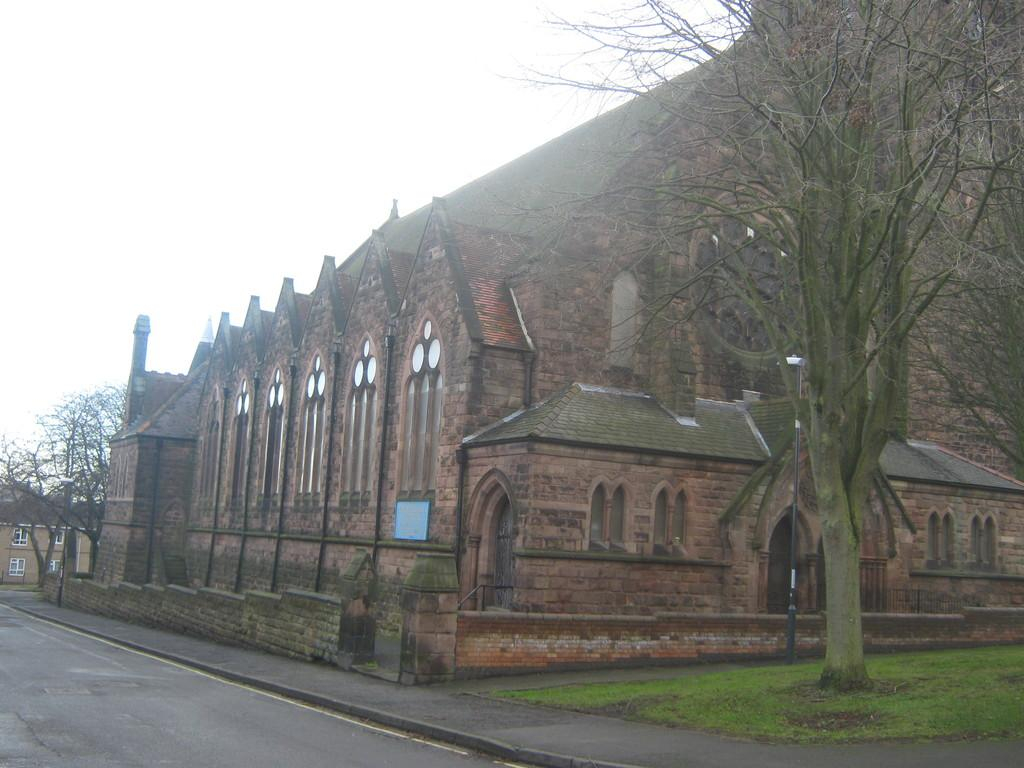What type of structures can be seen in the image? There are buildings in the image. What other natural elements are present in the image? There are trees and green grass visible in the image. What is visible at the top of the image? The sky is visible at the top of the image, and clouds are present in the sky. What can be seen at the bottom of the image? There is a road at the bottom of the image. Can you tell me how much grain is being sold in the image? There is no reference to grain or any transaction in the image. What country is depicted in the image? The image does not depict a specific country; it shows a general landscape with buildings, trees, sky, road, and grass. 